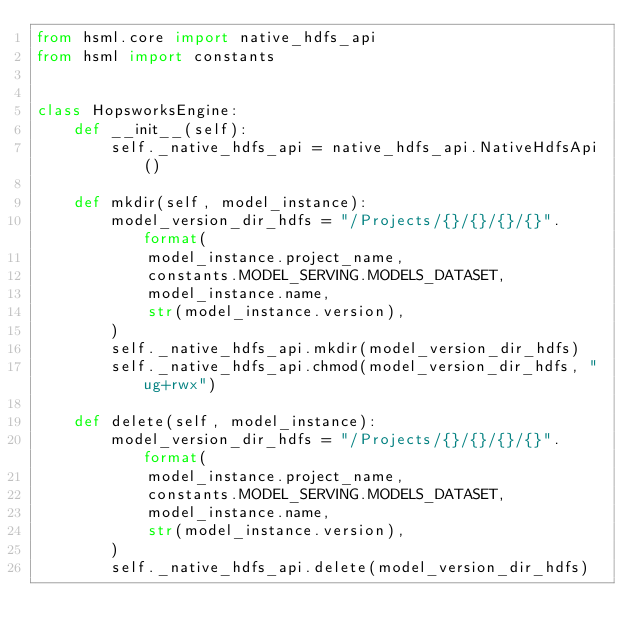Convert code to text. <code><loc_0><loc_0><loc_500><loc_500><_Python_>from hsml.core import native_hdfs_api
from hsml import constants


class HopsworksEngine:
    def __init__(self):
        self._native_hdfs_api = native_hdfs_api.NativeHdfsApi()

    def mkdir(self, model_instance):
        model_version_dir_hdfs = "/Projects/{}/{}/{}/{}".format(
            model_instance.project_name,
            constants.MODEL_SERVING.MODELS_DATASET,
            model_instance.name,
            str(model_instance.version),
        )
        self._native_hdfs_api.mkdir(model_version_dir_hdfs)
        self._native_hdfs_api.chmod(model_version_dir_hdfs, "ug+rwx")

    def delete(self, model_instance):
        model_version_dir_hdfs = "/Projects/{}/{}/{}/{}".format(
            model_instance.project_name,
            constants.MODEL_SERVING.MODELS_DATASET,
            model_instance.name,
            str(model_instance.version),
        )
        self._native_hdfs_api.delete(model_version_dir_hdfs)
</code> 